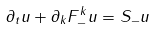<formula> <loc_0><loc_0><loc_500><loc_500>\partial _ { t } { u } + \partial _ { k } F ^ { k } _ { - } { u } = S _ { - } { u }</formula> 